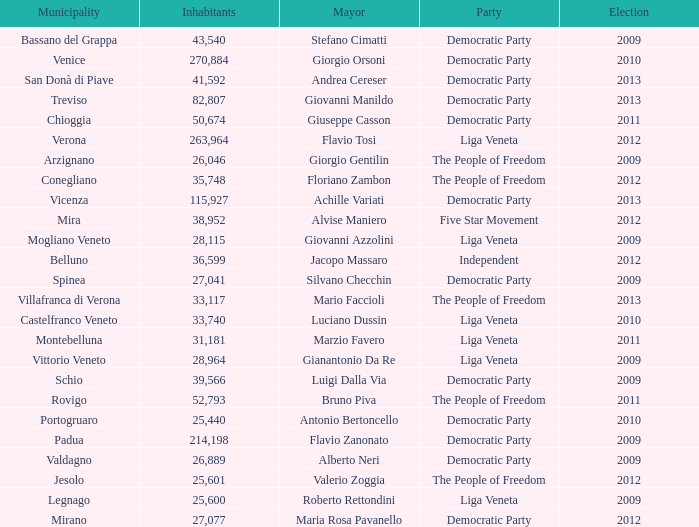What party was achille variati afilliated with? Democratic Party. 